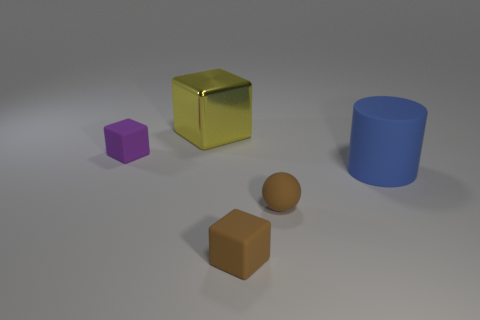Is there anything else that has the same material as the yellow cube?
Ensure brevity in your answer.  No. There is a sphere that is the same size as the brown rubber block; what color is it?
Offer a very short reply. Brown. There is a tiny rubber cube that is behind the sphere; how many cylinders are on the right side of it?
Make the answer very short. 1. What number of things are rubber blocks to the right of the yellow object or brown matte spheres?
Provide a short and direct response. 2. How many purple cubes are made of the same material as the tiny sphere?
Your answer should be compact. 1. What is the shape of the thing that is the same color as the tiny rubber sphere?
Provide a short and direct response. Cube. Is the number of purple things that are on the right side of the big blue matte object the same as the number of rubber cubes?
Give a very brief answer. No. What is the size of the brown object on the left side of the tiny sphere?
Keep it short and to the point. Small. What number of large things are brown metal cubes or blue objects?
Your answer should be very brief. 1. What color is the big shiny object that is the same shape as the purple matte object?
Ensure brevity in your answer.  Yellow. 